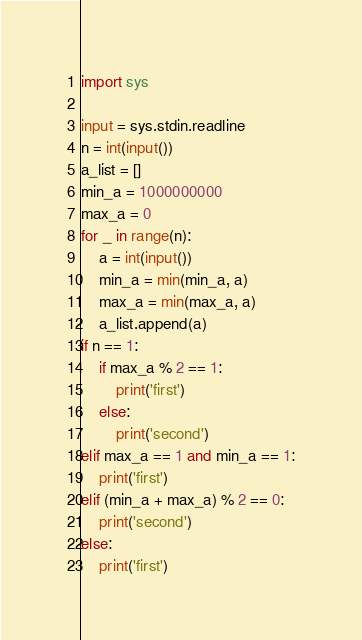<code> <loc_0><loc_0><loc_500><loc_500><_Python_>import sys

input = sys.stdin.readline
n = int(input())
a_list = []
min_a = 1000000000
max_a = 0
for _ in range(n):
    a = int(input())
    min_a = min(min_a, a)
    max_a = min(max_a, a)
    a_list.append(a)
if n == 1:
    if max_a % 2 == 1:
        print('first')
    else:
        print('second')
elif max_a == 1 and min_a == 1:
    print('first')
elif (min_a + max_a) % 2 == 0:
    print('second')
else:
    print('first')
</code> 